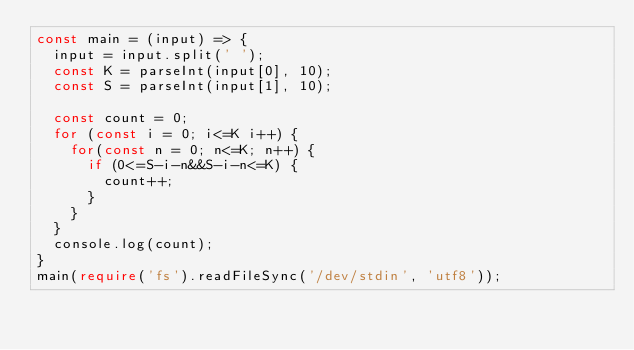<code> <loc_0><loc_0><loc_500><loc_500><_TypeScript_>const main = (input) => {
  input = input.split(' ');
  const K = parseInt(input[0], 10);
  const S = parseInt(input[1], 10);
  
  const count = 0;
  for (const i = 0; i<=K i++) {
    for(const n = 0; n<=K; n++) {
      if (0<=S-i-n&&S-i-n<=K) {
        count++;
      }
    }
  }
  console.log(count);
}
main(require('fs').readFileSync('/dev/stdin', 'utf8'));</code> 